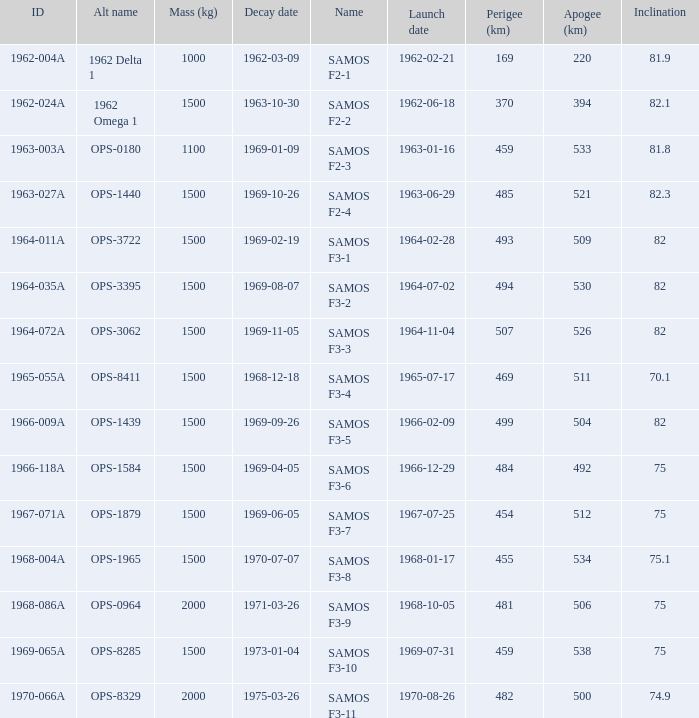What was the maximum perigee on 1969-01-09? 459.0. 